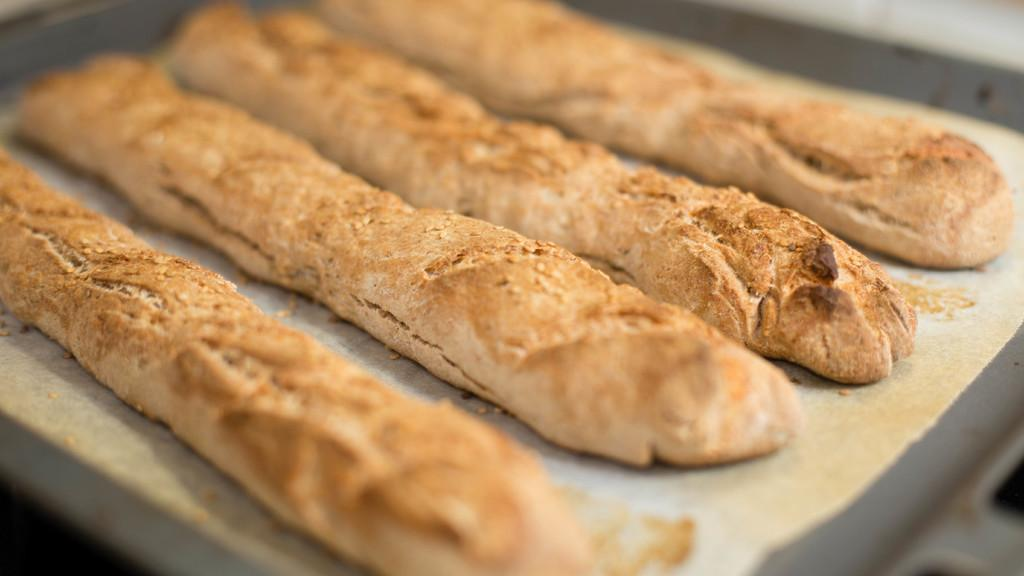What is present on the plate in the image? There are many breadsticks on the plate in the image. Can you describe the appearance of the breadsticks? The breadsticks are numerous and placed on the plate. What type of straw is used to create the designs on the plate? There is no straw present in the image, and no designs are mentioned on the plate. How many cars are parked next to the plate in the image? There are no cars present in the image. 